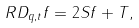<formula> <loc_0><loc_0><loc_500><loc_500>R D _ { q , t } f = 2 S f + T ,</formula> 